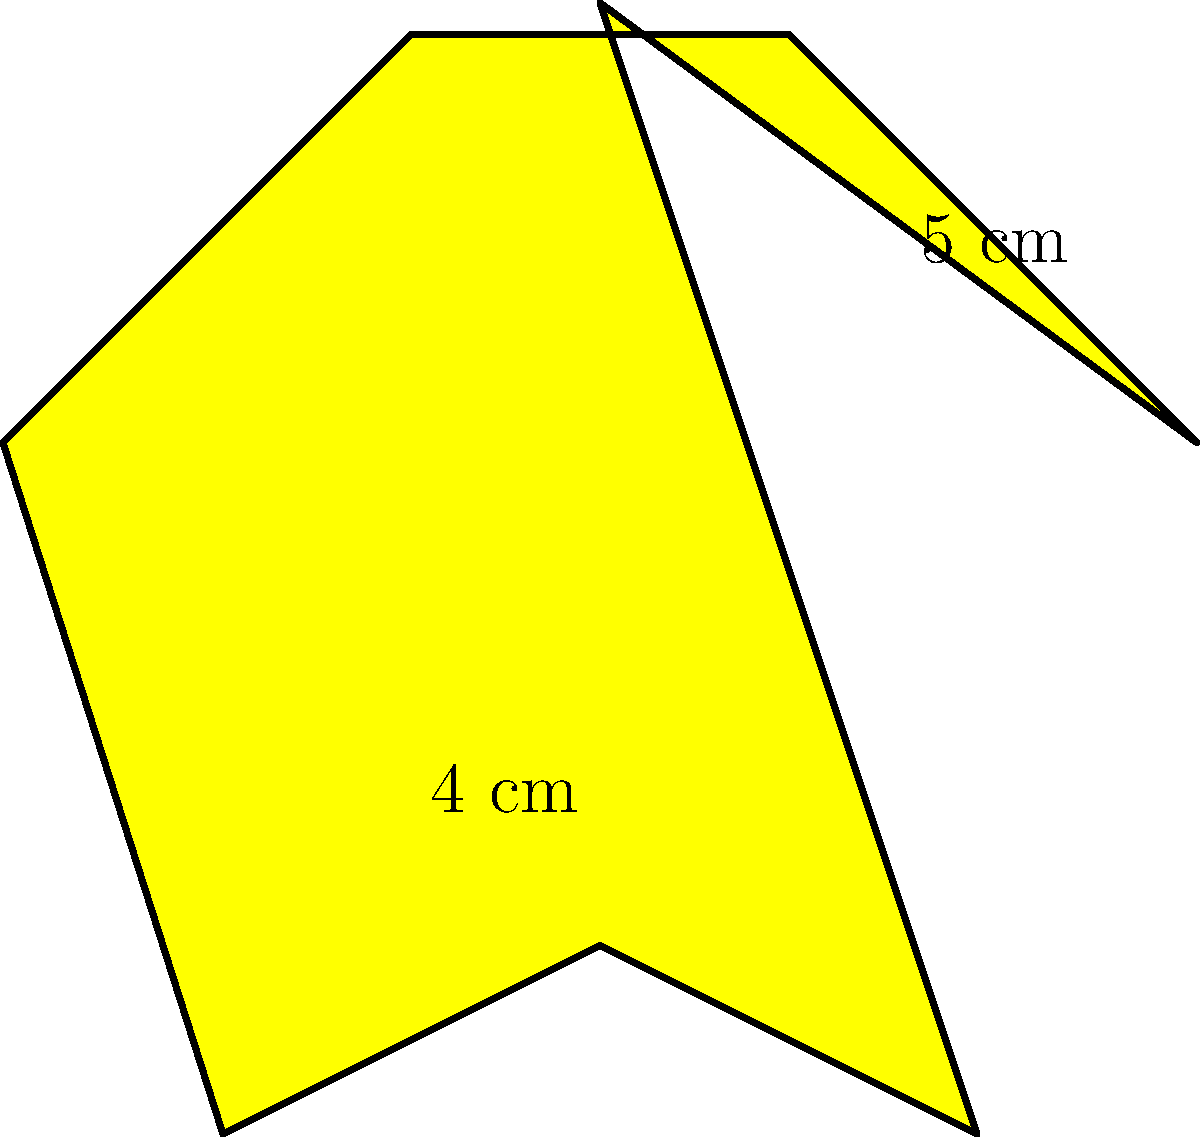For a seasonal promotion, you plan to create star-shaped window decals. The star shape can be approximated by an 8-pointed polygon, as shown in the diagram. If the distance from the center to any point is 5 cm, and the inner radius (distance from the center to the midpoint of any side) is 4 cm, calculate the total area of 50 such decals. Round your answer to the nearest square centimeter. Let's approach this step-by-step:

1) First, we need to find the area of one star-shaped decal.

2) The star can be divided into 8 congruent triangles. If we can find the area of one triangle and multiply by 8, we'll have the area of the star.

3) Each triangle has:
   - Base (b): the distance between two adjacent points on the star's perimeter
   - Height (h): 5 cm (the radius to any point)

4) To find the base, we can use the Pythagorean theorem:
   $b^2 + 4^2 = 5^2$
   $b^2 = 25 - 16 = 9$
   $b = 3$ cm

5) Now we can calculate the area of one triangle:
   Area of triangle = $\frac{1}{2} \times base \times height$
                    = $\frac{1}{2} \times 3 \times 5 = 7.5$ sq cm

6) Area of the star = 8 × Area of one triangle
                    = $8 \times 7.5 = 60$ sq cm

7) For 50 decals:
   Total area = $50 \times 60 = 3000$ sq cm

Therefore, the total area of 50 star-shaped decals is 3000 square centimeters.
Answer: 3000 sq cm 